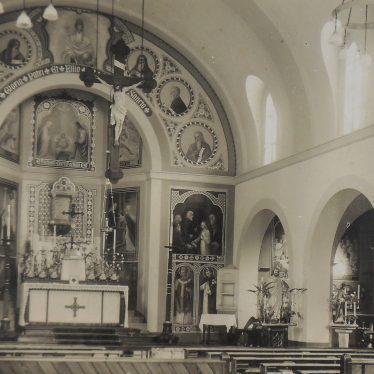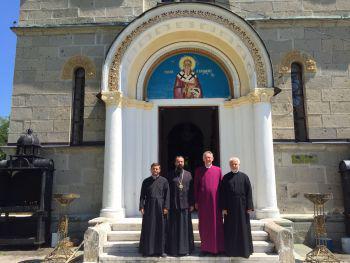The first image is the image on the left, the second image is the image on the right. For the images shown, is this caption "Multiple people stand in front of an arch in one image." true? Answer yes or no. Yes. The first image is the image on the left, the second image is the image on the right. For the images displayed, is the sentence "In one image, an ornate arched entry with columns and a colored painting under the arch is set in an outside stone wall of a building." factually correct? Answer yes or no. Yes. 